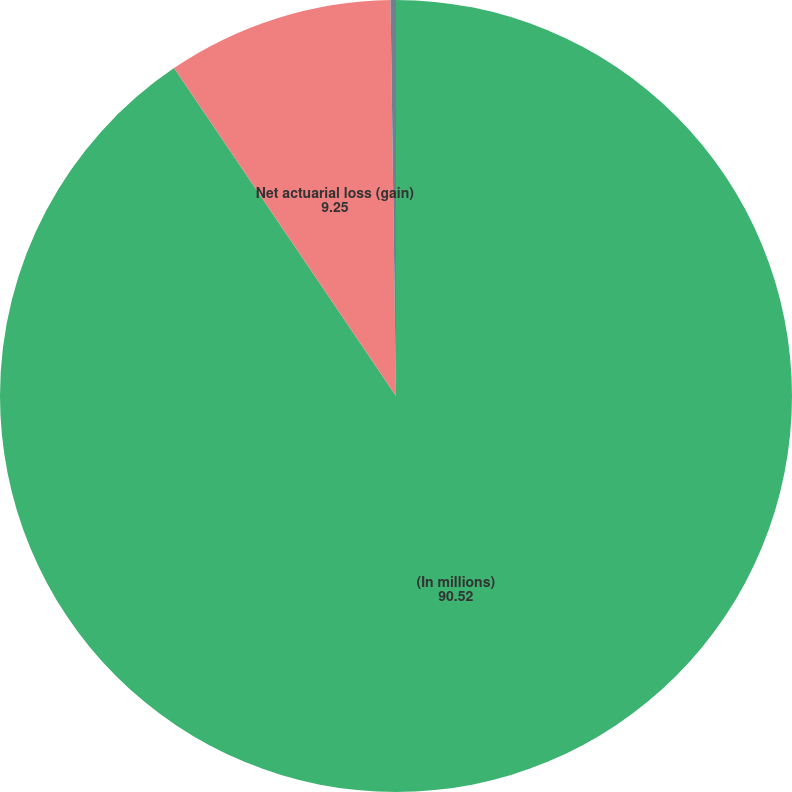Convert chart. <chart><loc_0><loc_0><loc_500><loc_500><pie_chart><fcel>(In millions)<fcel>Net actuarial loss (gain)<fcel>Net actuarial loss<nl><fcel>90.52%<fcel>9.25%<fcel>0.22%<nl></chart> 